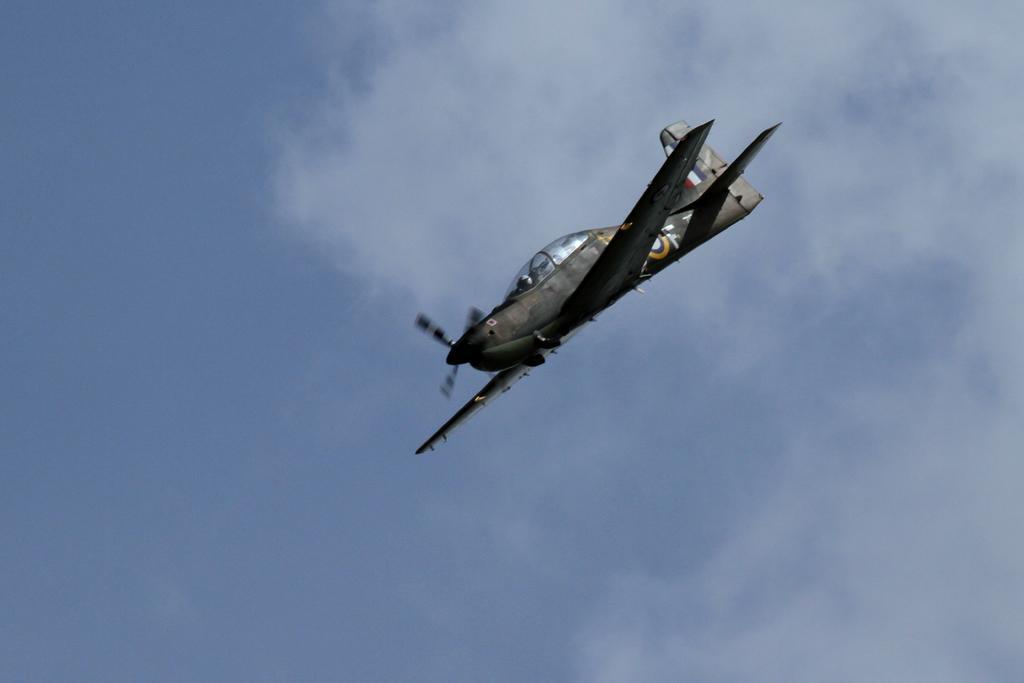Could you give a brief overview of what you see in this image? In this picture there is a man who is wearing helmet. He is sitting inside the plane. In the back we can see sky and clouds. 